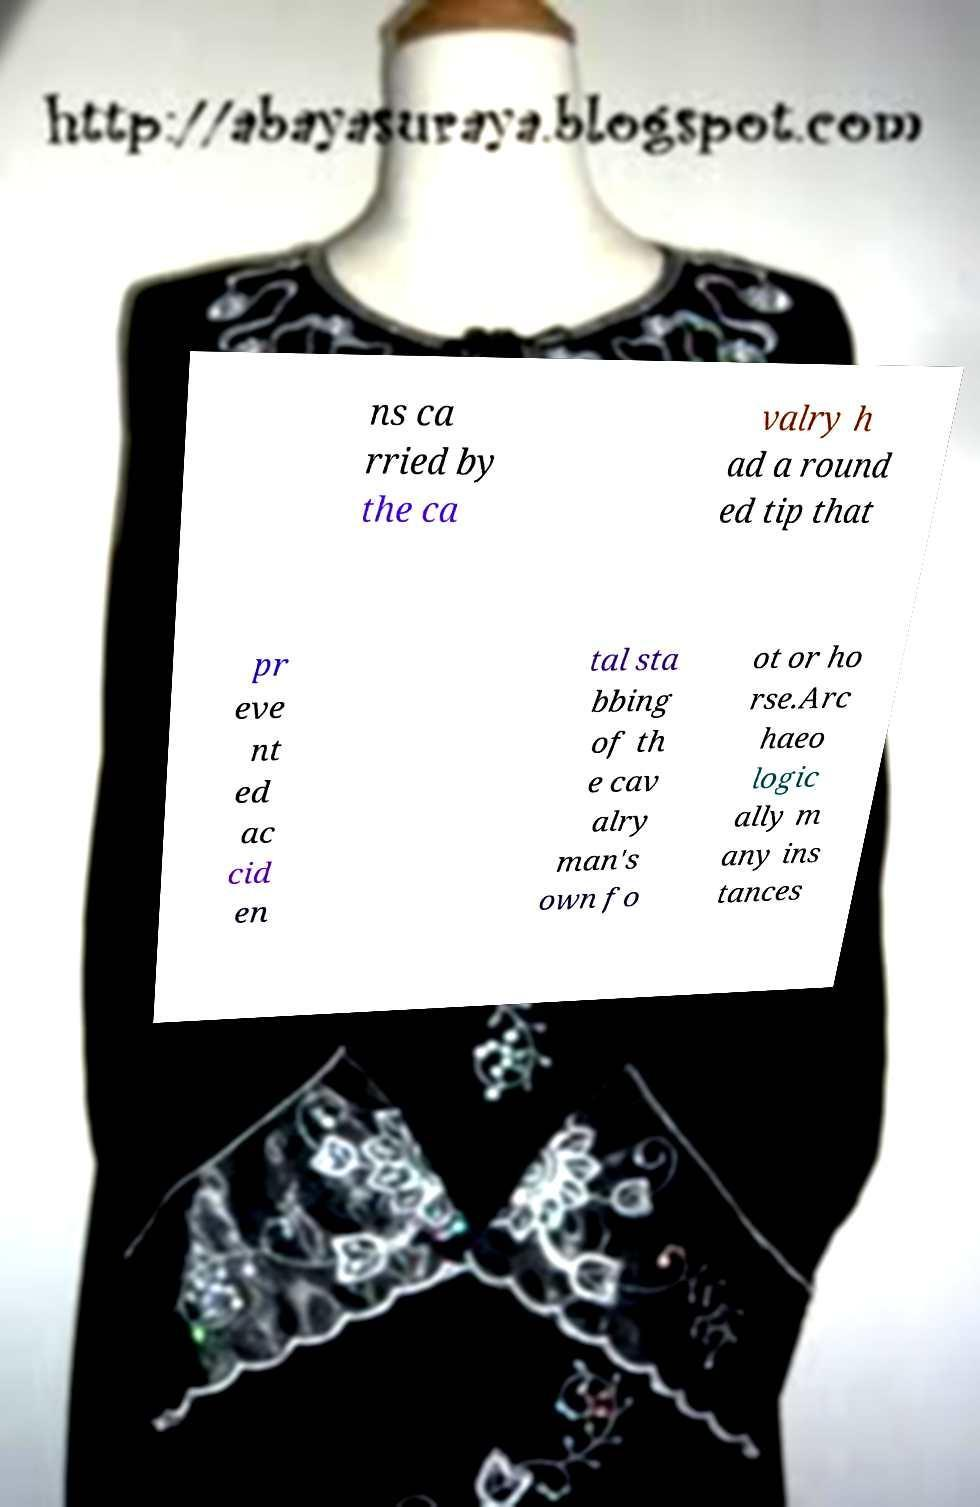Can you read and provide the text displayed in the image?This photo seems to have some interesting text. Can you extract and type it out for me? ns ca rried by the ca valry h ad a round ed tip that pr eve nt ed ac cid en tal sta bbing of th e cav alry man's own fo ot or ho rse.Arc haeo logic ally m any ins tances 